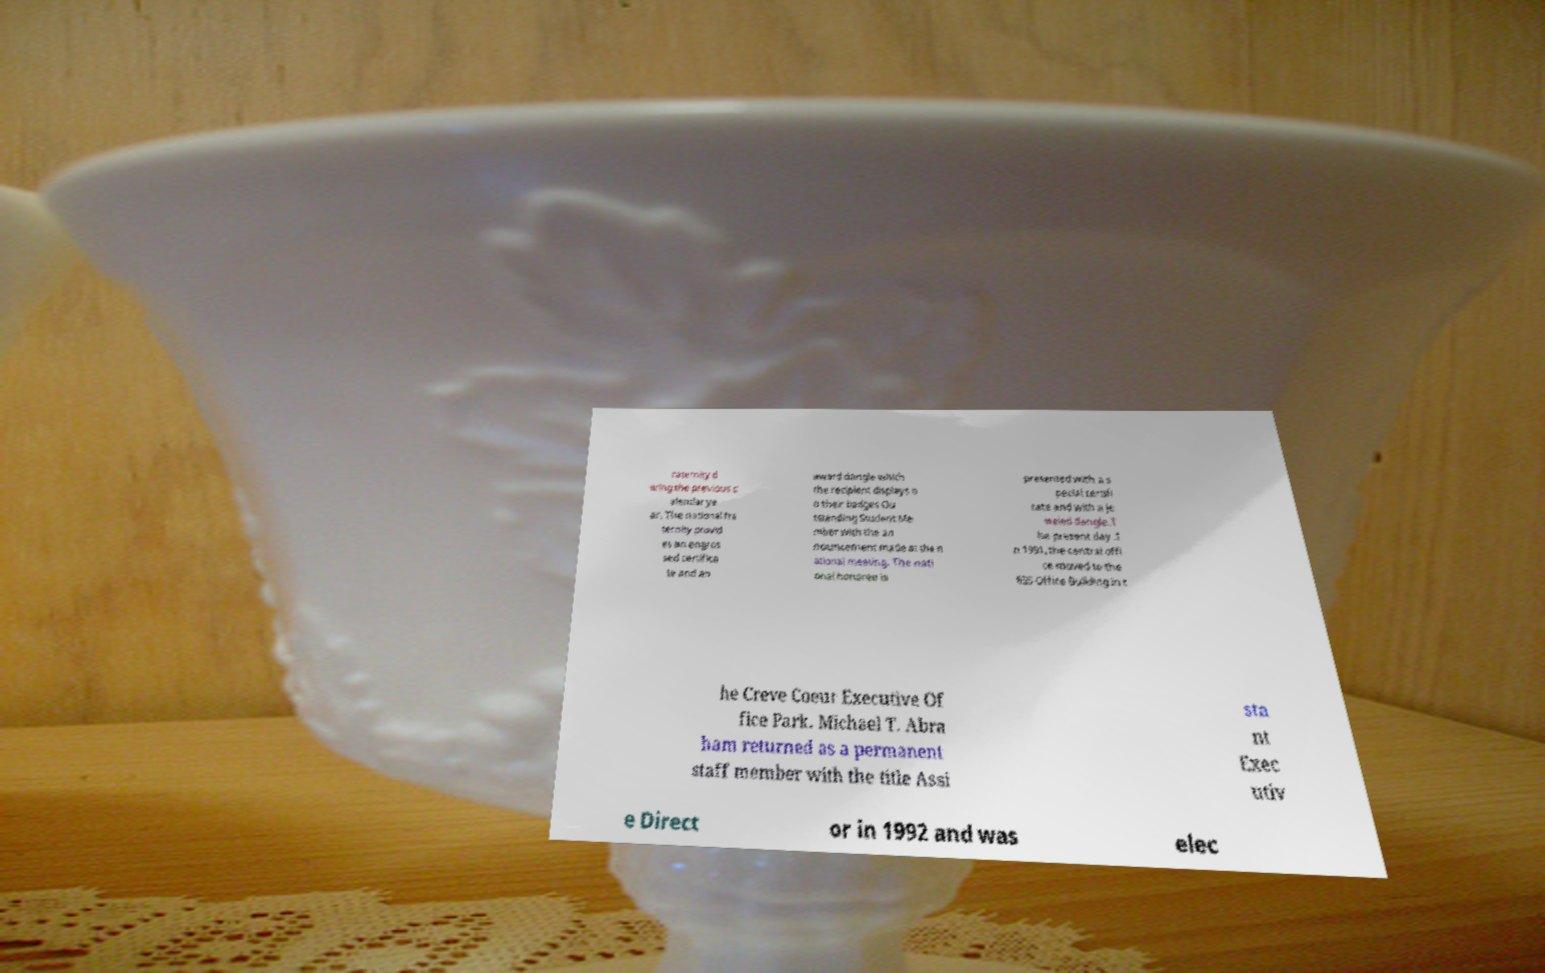For documentation purposes, I need the text within this image transcribed. Could you provide that? raternity d uring the previous c alendar ye ar. The national fra ternity provid es an engros sed certifica te and an award dangle which the recipient displays o n their badges Ou tstanding Student Me mber with the an nouncement made at the n ational meeting. The nati onal honoree is presented with a s pecial certifi cate and with a je weled dangle.T he present day .I n 1991, the central offi ce moved to the 655 Office Building in t he Creve Coeur Executive Of fice Park. Michael T. Abra ham returned as a permanent staff member with the title Assi sta nt Exec utiv e Direct or in 1992 and was elec 